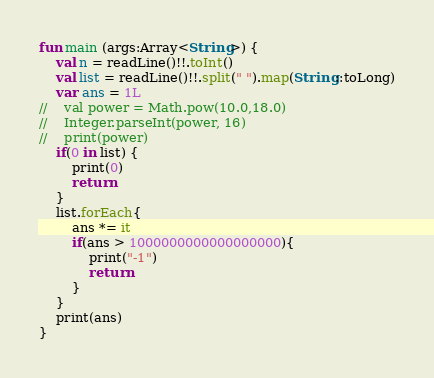<code> <loc_0><loc_0><loc_500><loc_500><_Kotlin_>fun main (args:Array<String>) {
    val n = readLine()!!.toInt()
    val list = readLine()!!.split(" ").map(String::toLong)
    var ans = 1L
//    val power = Math.pow(10.0,18.0)
//    Integer.parseInt(power, 16)
//    print(power)
    if(0 in list) {
        print(0)
        return
    }
    list.forEach{
        ans *= it
        if(ans > 1000000000000000000){
            print("-1")
            return
        }
    }
    print(ans)
}
</code> 